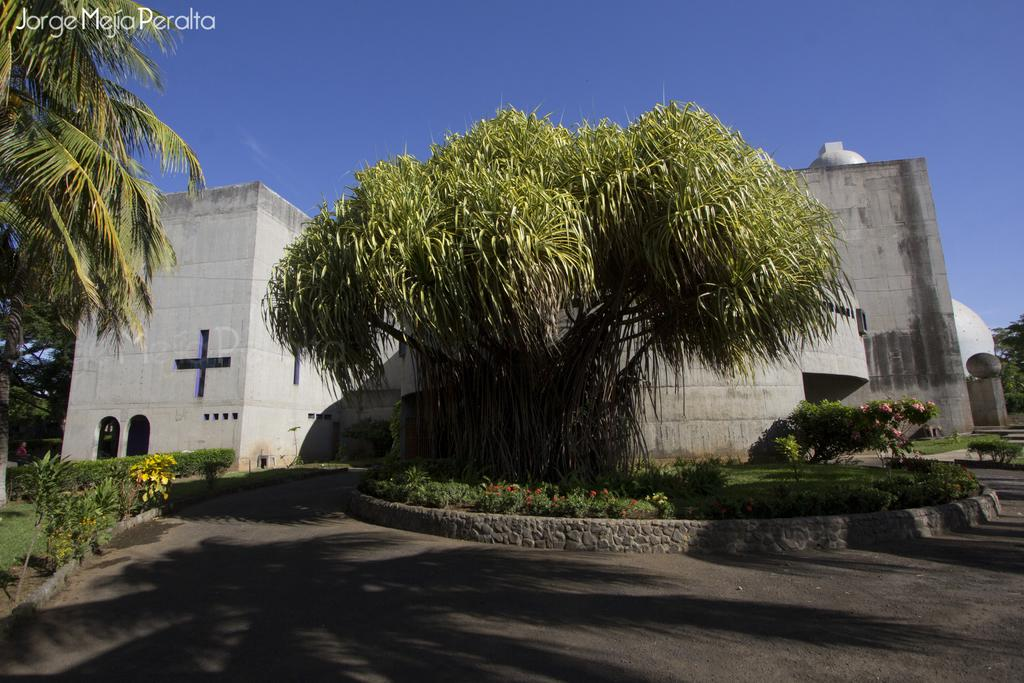What type of vegetation can be seen in the image? There is grass and plants in the image. What type of barrier is present in the image? There is a fence in the image. What type of natural structures are visible in the image? There are trees in the image. What type of man-made structures are visible in the image? There are buildings in the image. Who or what is present in the image? There is a person in the image. What architectural features can be seen in the image? There are windows in the image. What type of text is present in the image? There is text in the image. What part of the natural environment is visible in the image? The sky is visible in the image. What might be the location of the image? The image may have been taken on a road. What type of cable can be seen connecting the person to the trees in the image? There is no cable present in the image connecting the person to the trees. What type of voice can be heard coming from the person in the image? There is no audio present in the image, so it is not possible to determine if a voice can be heard. 